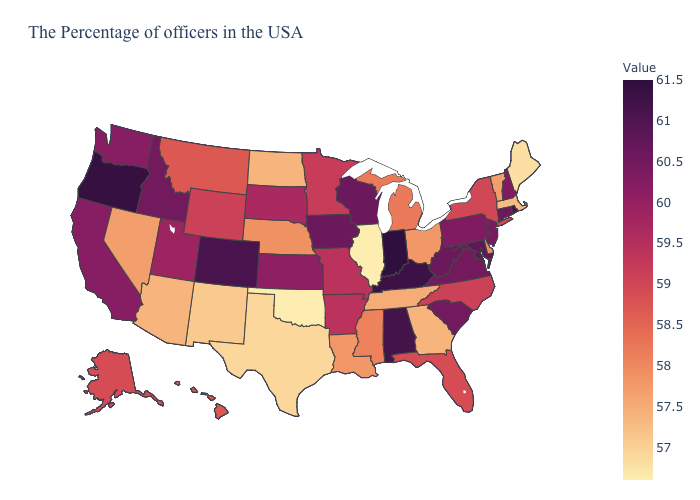Does Indiana have the highest value in the MidWest?
Be succinct. Yes. Among the states that border Massachusetts , which have the lowest value?
Concise answer only. Vermont. Does the map have missing data?
Be succinct. No. 